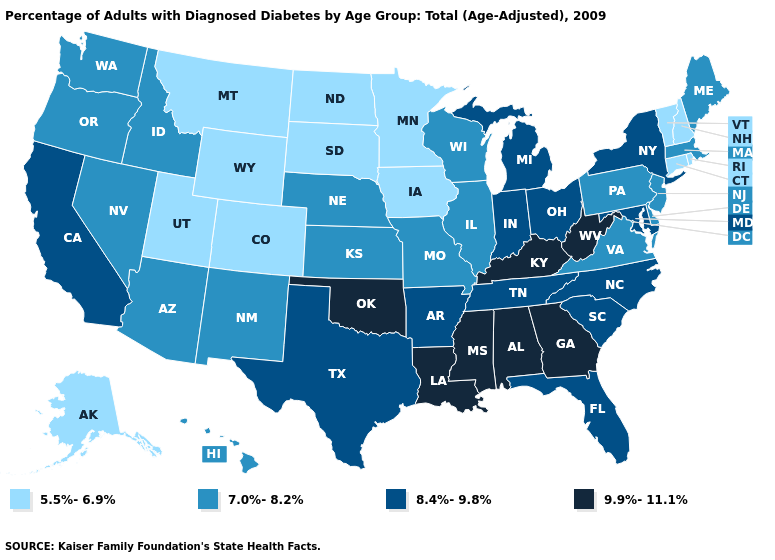What is the value of Arizona?
Give a very brief answer. 7.0%-8.2%. Name the states that have a value in the range 8.4%-9.8%?
Short answer required. Arkansas, California, Florida, Indiana, Maryland, Michigan, New York, North Carolina, Ohio, South Carolina, Tennessee, Texas. What is the highest value in states that border Indiana?
Write a very short answer. 9.9%-11.1%. Which states hav the highest value in the MidWest?
Write a very short answer. Indiana, Michigan, Ohio. What is the lowest value in states that border Montana?
Short answer required. 5.5%-6.9%. What is the value of Montana?
Give a very brief answer. 5.5%-6.9%. Name the states that have a value in the range 8.4%-9.8%?
Concise answer only. Arkansas, California, Florida, Indiana, Maryland, Michigan, New York, North Carolina, Ohio, South Carolina, Tennessee, Texas. Does New Mexico have a higher value than Ohio?
Answer briefly. No. Which states hav the highest value in the Northeast?
Answer briefly. New York. What is the highest value in states that border Maryland?
Keep it brief. 9.9%-11.1%. What is the value of Minnesota?
Give a very brief answer. 5.5%-6.9%. Name the states that have a value in the range 8.4%-9.8%?
Keep it brief. Arkansas, California, Florida, Indiana, Maryland, Michigan, New York, North Carolina, Ohio, South Carolina, Tennessee, Texas. Name the states that have a value in the range 7.0%-8.2%?
Write a very short answer. Arizona, Delaware, Hawaii, Idaho, Illinois, Kansas, Maine, Massachusetts, Missouri, Nebraska, Nevada, New Jersey, New Mexico, Oregon, Pennsylvania, Virginia, Washington, Wisconsin. Name the states that have a value in the range 5.5%-6.9%?
Be succinct. Alaska, Colorado, Connecticut, Iowa, Minnesota, Montana, New Hampshire, North Dakota, Rhode Island, South Dakota, Utah, Vermont, Wyoming. Name the states that have a value in the range 8.4%-9.8%?
Quick response, please. Arkansas, California, Florida, Indiana, Maryland, Michigan, New York, North Carolina, Ohio, South Carolina, Tennessee, Texas. 